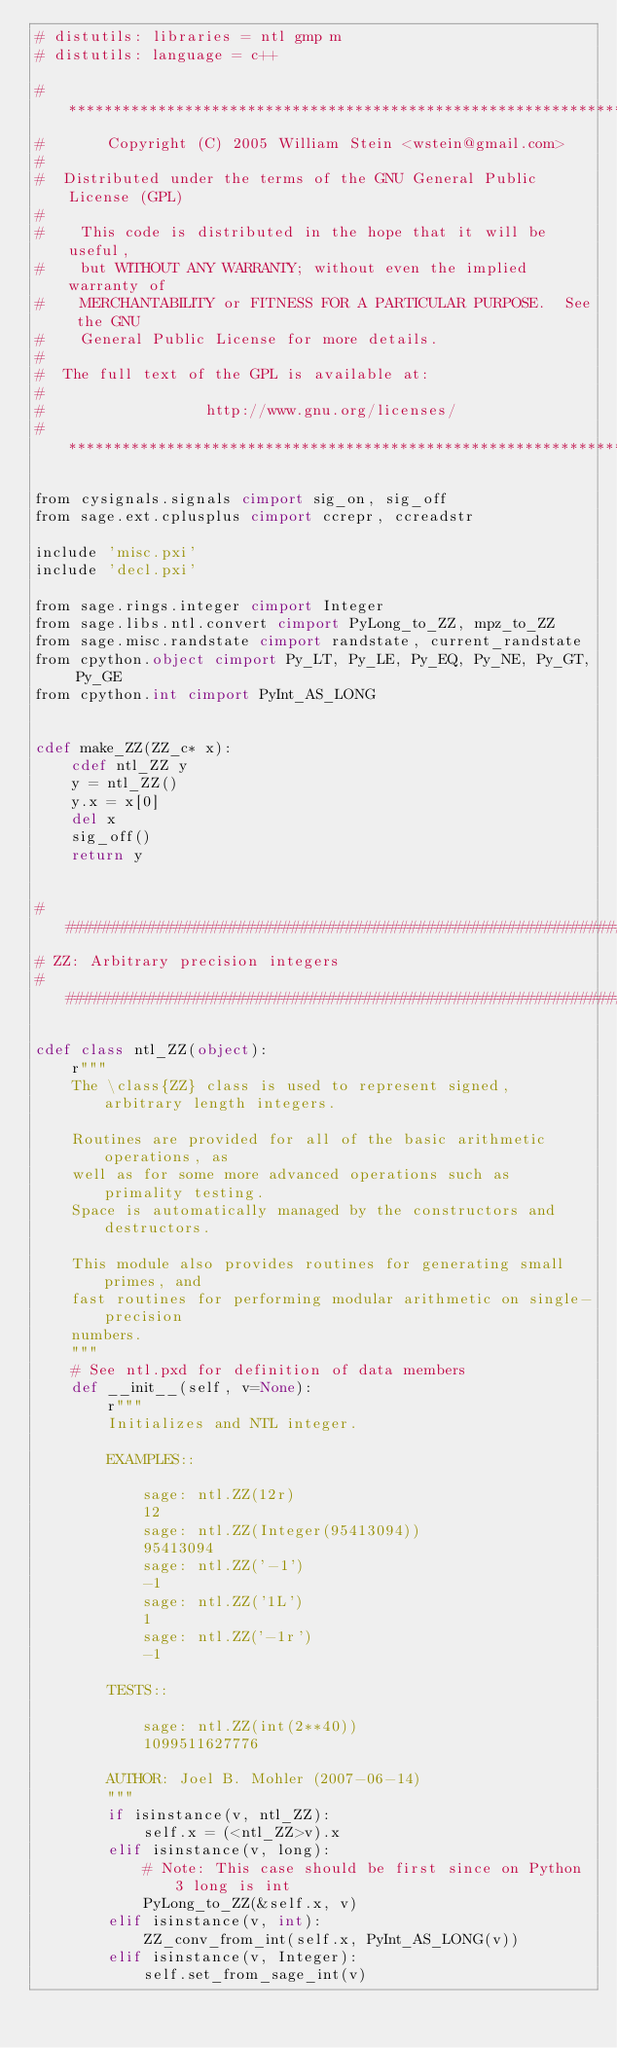Convert code to text. <code><loc_0><loc_0><loc_500><loc_500><_Cython_># distutils: libraries = ntl gmp m
# distutils: language = c++

#*****************************************************************************
#       Copyright (C) 2005 William Stein <wstein@gmail.com>
#
#  Distributed under the terms of the GNU General Public License (GPL)
#
#    This code is distributed in the hope that it will be useful,
#    but WITHOUT ANY WARRANTY; without even the implied warranty of
#    MERCHANTABILITY or FITNESS FOR A PARTICULAR PURPOSE.  See the GNU
#    General Public License for more details.
#
#  The full text of the GPL is available at:
#
#                  http://www.gnu.org/licenses/
#*****************************************************************************

from cysignals.signals cimport sig_on, sig_off
from sage.ext.cplusplus cimport ccrepr, ccreadstr

include 'misc.pxi'
include 'decl.pxi'

from sage.rings.integer cimport Integer
from sage.libs.ntl.convert cimport PyLong_to_ZZ, mpz_to_ZZ
from sage.misc.randstate cimport randstate, current_randstate
from cpython.object cimport Py_LT, Py_LE, Py_EQ, Py_NE, Py_GT, Py_GE
from cpython.int cimport PyInt_AS_LONG


cdef make_ZZ(ZZ_c* x):
    cdef ntl_ZZ y
    y = ntl_ZZ()
    y.x = x[0]
    del x
    sig_off()
    return y


##############################################################################
# ZZ: Arbitrary precision integers
##############################################################################

cdef class ntl_ZZ(object):
    r"""
    The \class{ZZ} class is used to represent signed, arbitrary length integers.

    Routines are provided for all of the basic arithmetic operations, as
    well as for some more advanced operations such as primality testing.
    Space is automatically managed by the constructors and destructors.

    This module also provides routines for generating small primes, and
    fast routines for performing modular arithmetic on single-precision
    numbers.
    """
    # See ntl.pxd for definition of data members
    def __init__(self, v=None):
        r"""
        Initializes and NTL integer.

        EXAMPLES::

            sage: ntl.ZZ(12r)
            12
            sage: ntl.ZZ(Integer(95413094))
            95413094
            sage: ntl.ZZ('-1')
            -1
            sage: ntl.ZZ('1L')
            1
            sage: ntl.ZZ('-1r')
            -1

        TESTS::

            sage: ntl.ZZ(int(2**40))
            1099511627776

        AUTHOR: Joel B. Mohler (2007-06-14)
        """
        if isinstance(v, ntl_ZZ):
            self.x = (<ntl_ZZ>v).x
        elif isinstance(v, long):
            # Note: This case should be first since on Python 3 long is int
            PyLong_to_ZZ(&self.x, v)
        elif isinstance(v, int):
            ZZ_conv_from_int(self.x, PyInt_AS_LONG(v))
        elif isinstance(v, Integer):
            self.set_from_sage_int(v)</code> 